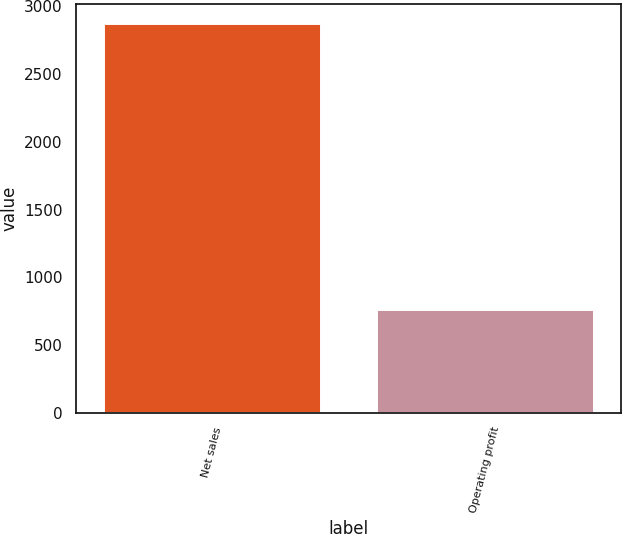<chart> <loc_0><loc_0><loc_500><loc_500><bar_chart><fcel>Net sales<fcel>Operating profit<nl><fcel>2878<fcel>768<nl></chart> 